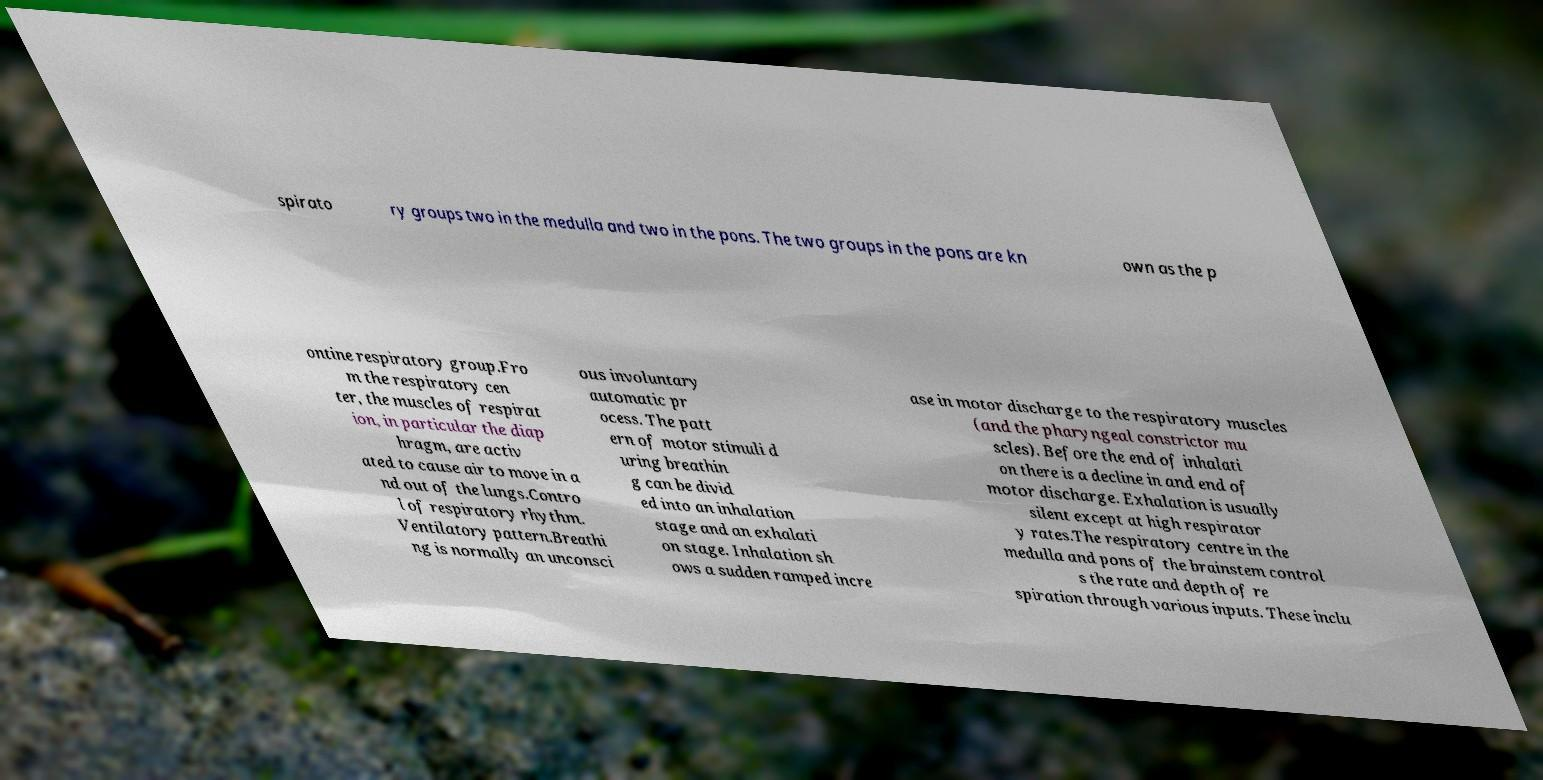Please read and relay the text visible in this image. What does it say? spirato ry groups two in the medulla and two in the pons. The two groups in the pons are kn own as the p ontine respiratory group.Fro m the respiratory cen ter, the muscles of respirat ion, in particular the diap hragm, are activ ated to cause air to move in a nd out of the lungs.Contro l of respiratory rhythm. Ventilatory pattern.Breathi ng is normally an unconsci ous involuntary automatic pr ocess. The patt ern of motor stimuli d uring breathin g can be divid ed into an inhalation stage and an exhalati on stage. Inhalation sh ows a sudden ramped incre ase in motor discharge to the respiratory muscles (and the pharyngeal constrictor mu scles). Before the end of inhalati on there is a decline in and end of motor discharge. Exhalation is usually silent except at high respirator y rates.The respiratory centre in the medulla and pons of the brainstem control s the rate and depth of re spiration through various inputs. These inclu 